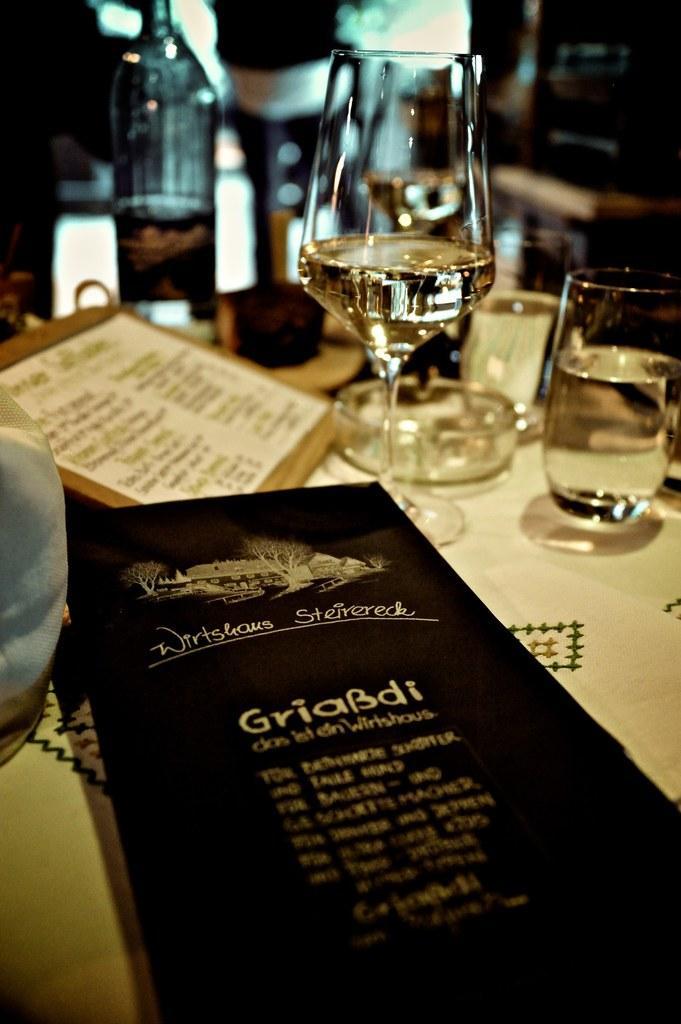Can you describe this image briefly? There is a table in the given picture on which some glasses, ashtrays and papers were placed. In the background there is a bottle. 